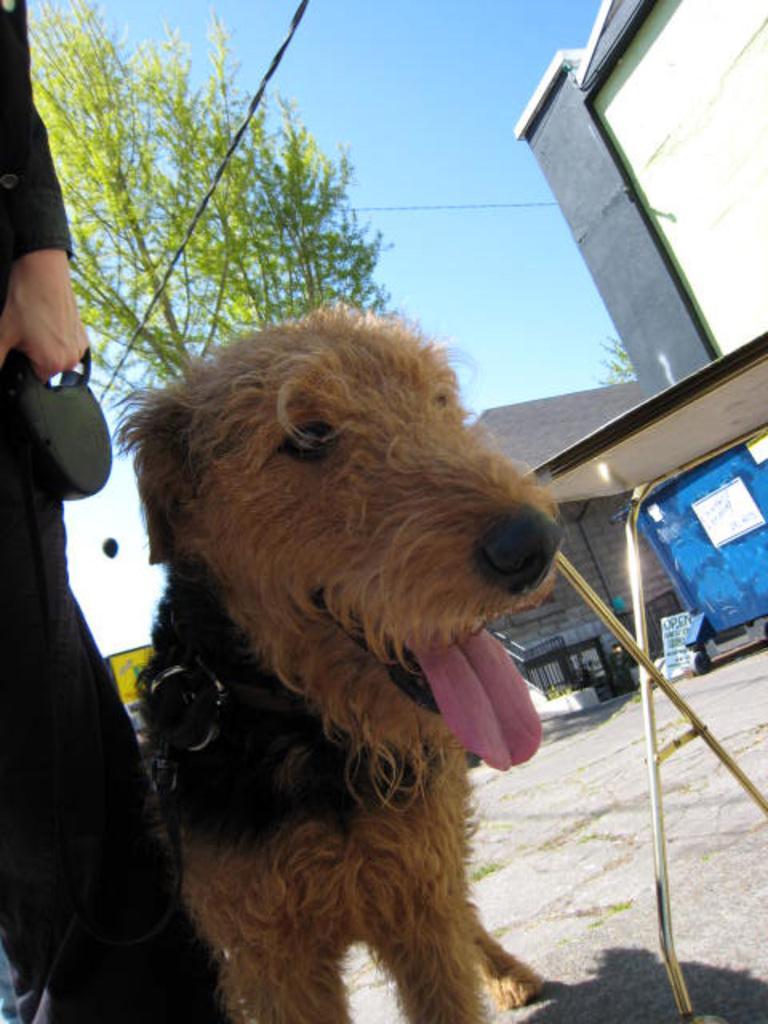Please provide a concise description of this image. In this image we can see a dog, a table, houses, trees, wires and also some person standing on the path. We can also see the sky. 